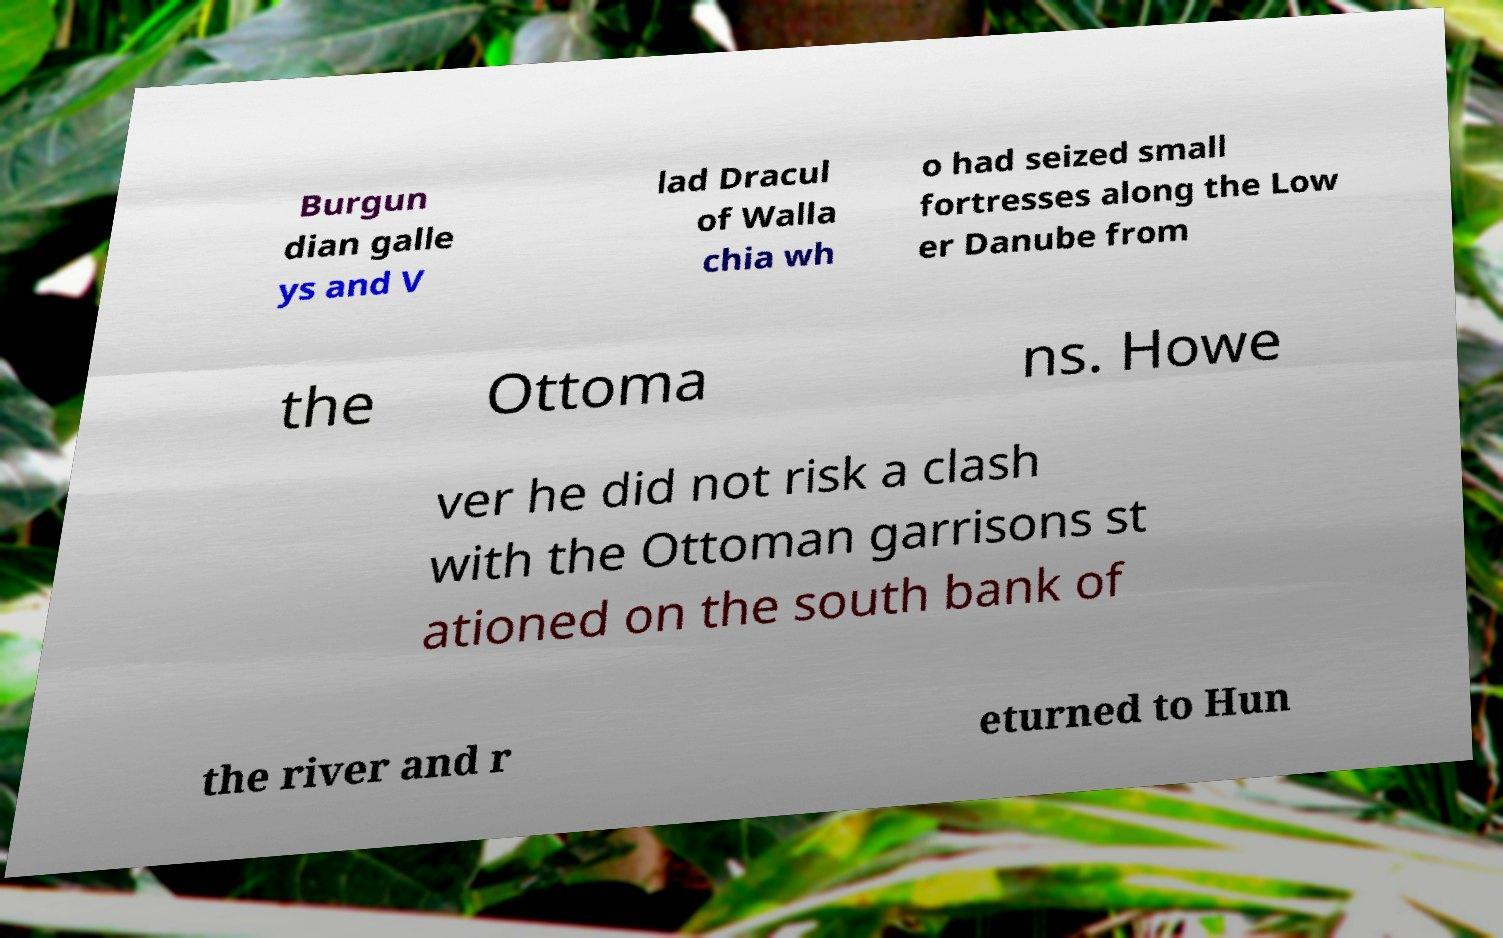For documentation purposes, I need the text within this image transcribed. Could you provide that? Burgun dian galle ys and V lad Dracul of Walla chia wh o had seized small fortresses along the Low er Danube from the Ottoma ns. Howe ver he did not risk a clash with the Ottoman garrisons st ationed on the south bank of the river and r eturned to Hun 